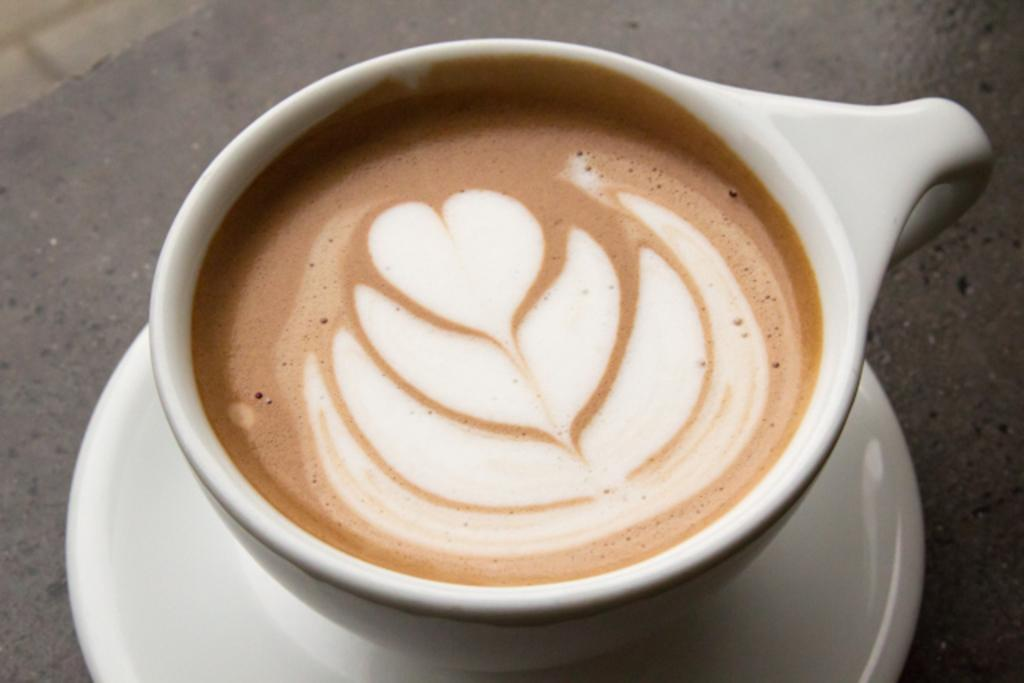What is in the cup that is visible in the image? There is a cup with coffee in the image. What decorative element is present on top of the coffee? There is an art made with foam on top of the coffee. What is the saucer used for in the image? The saucer is used to hold the cup and prevent spills. On what surface is the saucer placed in the image? The saucer is placed on a surface, which could be a table or countertop. What type of leather material is used to make the beam in the image? There is no beam or leather material present in the image; it features a cup of coffee with foam art and a saucer. 